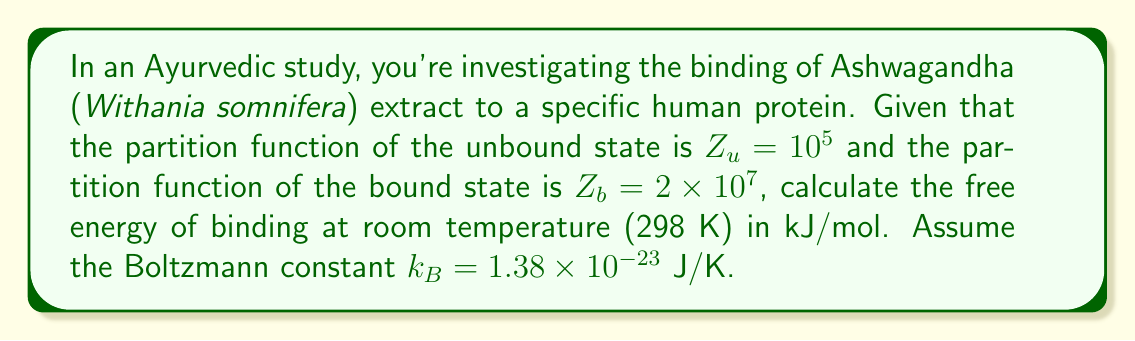Solve this math problem. To solve this problem, we'll use principles from statistical mechanics:

1) The free energy of binding (ΔG) is related to the partition functions of the bound and unbound states:

   $$\Delta G = -k_B T \ln \left(\frac{Z_b}{Z_u}\right)$$

2) Let's substitute the given values:
   $T = 298$ K
   $Z_b = 2 \times 10^7$
   $Z_u = 10^5$
   $k_B = 1.38 \times 10^{-23}$ J/K

3) Calculate the ratio inside the logarithm:

   $$\frac{Z_b}{Z_u} = \frac{2 \times 10^7}{10^5} = 200$$

4) Now, let's calculate ΔG:

   $$\Delta G = -(1.38 \times 10^{-23} \text{ J/K})(298 \text{ K}) \ln(200)$$

5) Simplify:
   $$\Delta G = -4.11 \times 10^{-21} \text{ J} \times 5.30$$
   $$\Delta G = -2.18 \times 10^{-20} \text{ J}$$

6) Convert to kJ/mol:
   Multiply by Avogadro's number ($6.022 \times 10^{23}$ mol^-1) and divide by 1000 to convert J to kJ:

   $$\Delta G = -2.18 \times 10^{-20} \text{ J} \times \frac{6.022 \times 10^{23} \text{ mol}^{-1}}{1000 \text{ J/kJ}}$$
   $$\Delta G = -13.1 \text{ kJ/mol}$$
Answer: -13.1 kJ/mol 